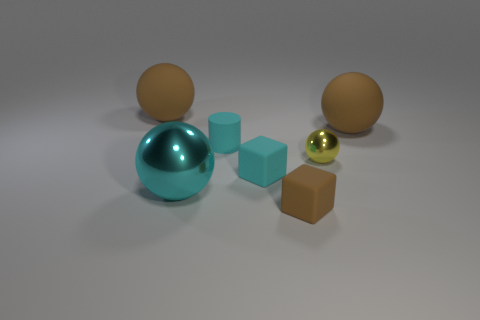Can you describe the lighting and shadows in the image? Certainly, the image appears to have a soft and diffused lighting setup. The shadows on the ground are soft-edged and elongated, indicating that the light source could be overhead and not very harsh, which creates no harsh shadows or overly bright highlights on the objects. This gives the scene a calm and even ambiance. 